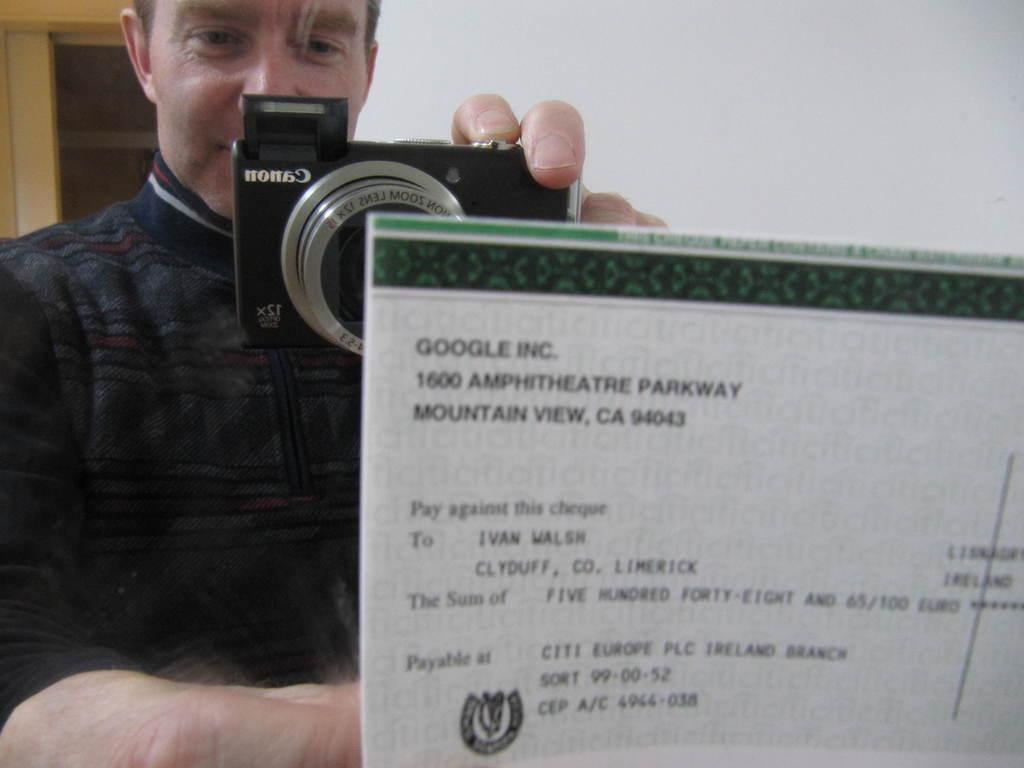What is the main subject of the image? There is a person in the image. What is the person holding in the image? The person is holding a camera. What else can be seen in front of the person? There is a paper in front of the person. How many monkeys are sitting on the paper in the image? There are no monkeys present in the image. 